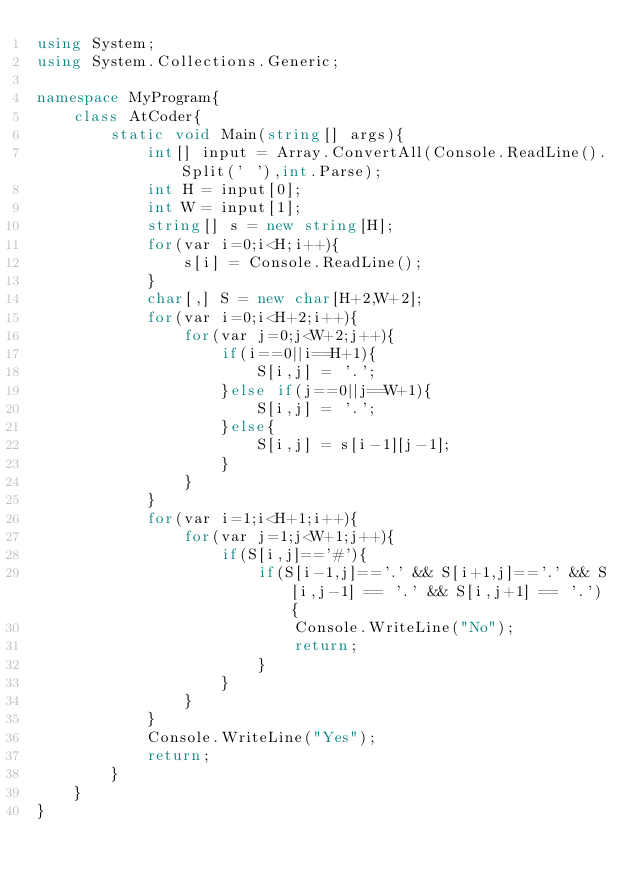Convert code to text. <code><loc_0><loc_0><loc_500><loc_500><_C#_>using System;
using System.Collections.Generic;

namespace MyProgram{
    class AtCoder{
        static void Main(string[] args){
            int[] input = Array.ConvertAll(Console.ReadLine().Split(' '),int.Parse);
            int H = input[0];
            int W = input[1];
            string[] s = new string[H];
            for(var i=0;i<H;i++){
                s[i] = Console.ReadLine();
            }
            char[,] S = new char[H+2,W+2];
            for(var i=0;i<H+2;i++){
                for(var j=0;j<W+2;j++){
                    if(i==0||i==H+1){
                        S[i,j] = '.';
                    }else if(j==0||j==W+1){
                        S[i,j] = '.';
                    }else{
                        S[i,j] = s[i-1][j-1];
                    }
                }
            }
            for(var i=1;i<H+1;i++){
                for(var j=1;j<W+1;j++){
                    if(S[i,j]=='#'){
                        if(S[i-1,j]=='.' && S[i+1,j]=='.' && S[i,j-1] == '.' && S[i,j+1] == '.'){
                            Console.WriteLine("No");
                            return;
                        }
                    }
                }
            }
            Console.WriteLine("Yes");
            return;
        }
    } 
}</code> 